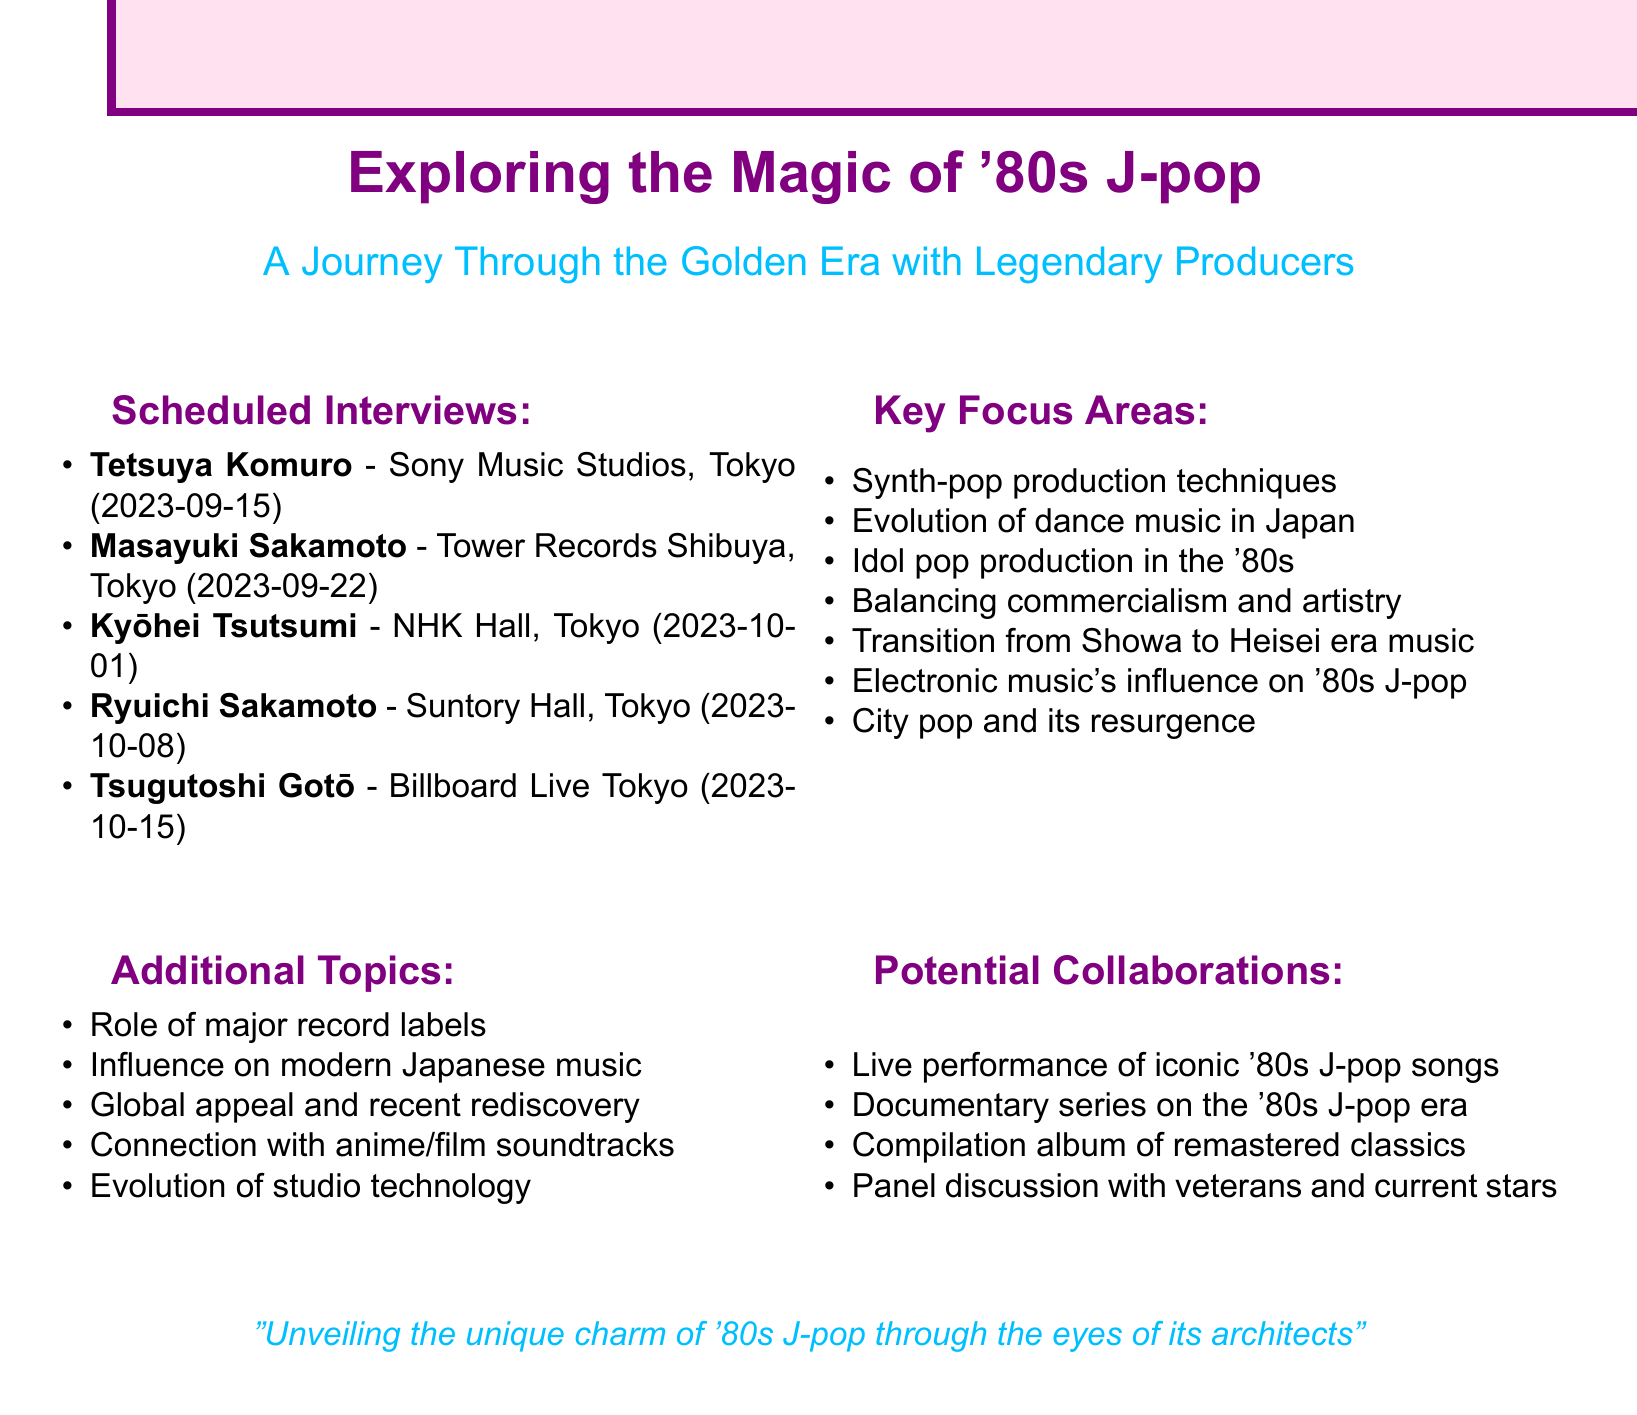What is the date of the interview with Tetsuya Komuro? The document specifies that the interview with Tetsuya Komuro is scheduled for 2023-09-15.
Answer: 2023-09-15 What is the venue for the interview with Masayuki Sakamoto? The document indicates that Masayuki Sakamoto's interview will take place at Tower Records Shibuya, Tokyo.
Answer: Tower Records Shibuya, Tokyo What notable work is associated with Ryuichi Sakamoto? The document lists Yellow Magic Orchestra as one of Ryuichi Sakamoto's notable works.
Answer: Yellow Magic Orchestra How many producers are scheduled for interviews according to the document? The document lists five producers scheduled for interviews.
Answer: Five Which producer is associated with city pop? The document states that Tsugutoshi Gotō is linked with city pop and its resurgence.
Answer: Tsugutoshi Gotō What additional topic involves the influence of '80s J-pop? The document mentions the influence of '80s J-pop on modern Japanese music as an additional topic.
Answer: Influence on modern Japanese music What is one potential collaboration mentioned in the document? The document suggests a live performance of iconic '80s J-pop songs as a potential collaboration.
Answer: Live performance of iconic '80s J-pop songs Which production technique is highlighted for its importance in '80s J-pop? The document identifies the importance of arrangement in '80s J-pop as a focus area.
Answer: Importance of arrangement Who is the producer associated with Pink Lady? The document notes that Kyōhei Tsutsumi is associated with Pink Lady.
Answer: Kyōhei Tsutsumi 